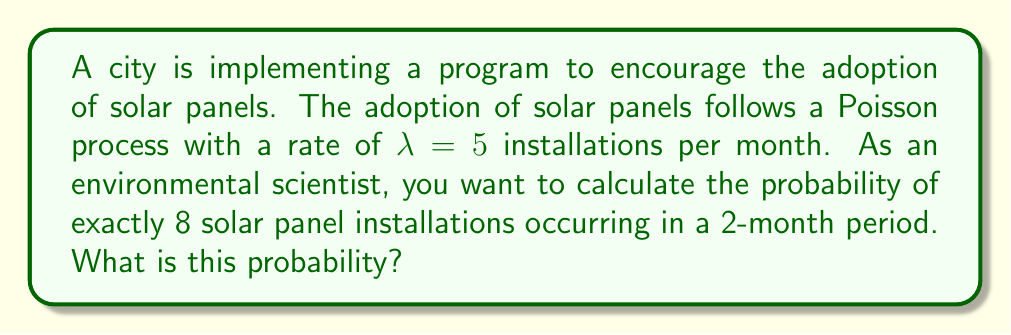Give your solution to this math problem. Let's approach this step-by-step:

1) In a Poisson process, the number of events in a fixed interval follows a Poisson distribution.

2) The Poisson distribution probability mass function is given by:

   $$P(X = k) = \frac{e^{-\lambda} \lambda^k}{k!}$$

   where $\lambda$ is the average number of events in the interval and $k$ is the number of events we're interested in.

3) We're given that $\lambda = 5$ installations per month. However, we're looking at a 2-month period, so we need to adjust $\lambda$:

   $\lambda_{2 months} = 5 * 2 = 10$

4) We want the probability of exactly 8 installations, so $k = 8$.

5) Plugging these values into the Poisson probability mass function:

   $$P(X = 8) = \frac{e^{-10} 10^8}{8!}$$

6) Now let's calculate this:
   
   $$P(X = 8) = \frac{e^{-10} 10^8}{8!} = \frac{2.2026 * 10^{-5} * 10^8}{40320} \approx 0.1126$$

7) Convert to a percentage: 0.1126 * 100% ≈ 11.26%

This result indicates that there's about an 11.26% chance of exactly 8 solar panel installations occurring in a 2-month period, given the specified adoption rate.
Answer: 11.26% 